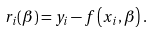Convert formula to latex. <formula><loc_0><loc_0><loc_500><loc_500>r _ { i } ( { \beta } ) = y _ { i } - f \left ( x _ { i } , { \beta } \right ) .</formula> 